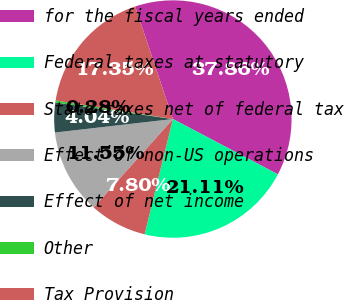Convert chart. <chart><loc_0><loc_0><loc_500><loc_500><pie_chart><fcel>for the fiscal years ended<fcel>Federal taxes at statutory<fcel>State taxes net of federal tax<fcel>Effect of non-US operations<fcel>Effect of net income<fcel>Other<fcel>Tax Provision<nl><fcel>37.86%<fcel>21.11%<fcel>7.8%<fcel>11.55%<fcel>4.04%<fcel>0.28%<fcel>17.35%<nl></chart> 